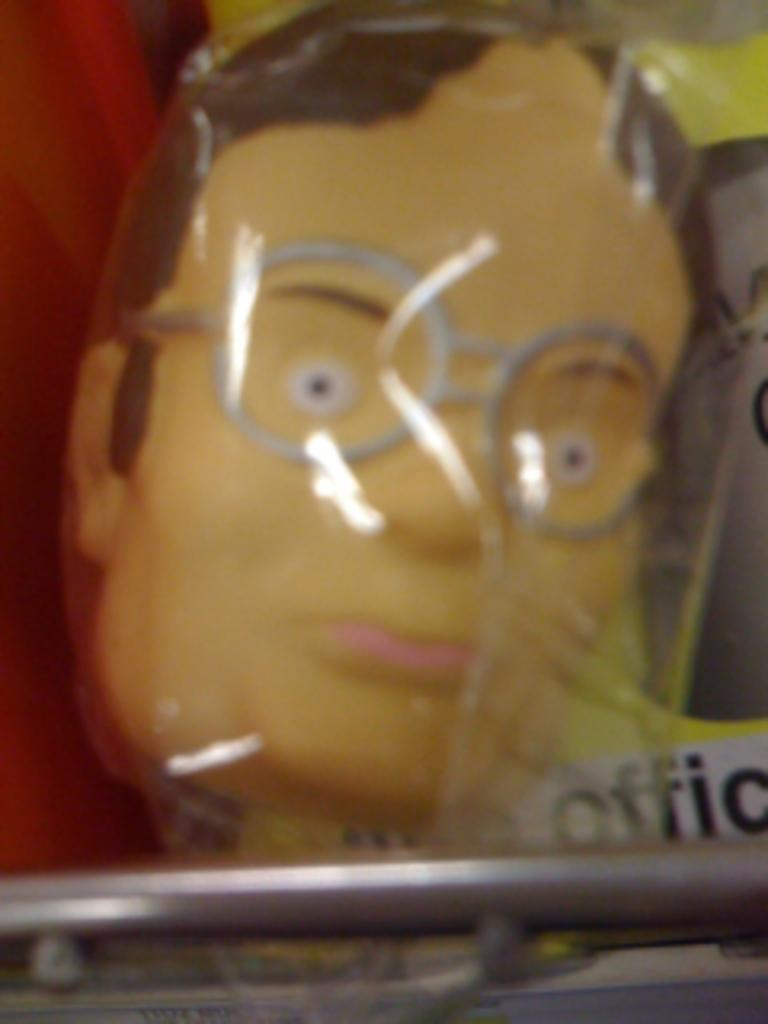What is located in the foreground of the image? There is a metal object and toys in the foreground of the image. What type of object with text can be seen in the image? There is an object with text, which seems to be a paper, in the image. Can you describe any other objects present in the image? There are other unspecified objects in the image. What direction are the trousers facing in the image? There are no trousers present in the image. How many quarters can be seen in the image? There are no quarters present in the image. 